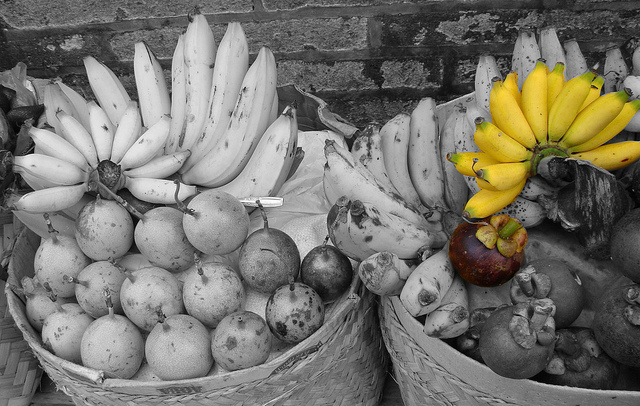Please provide the bounding box coordinate of the region this sentence describes: yellow bananas. The region corresponding to 'yellow bananas' is located at coordinates [0.69, 0.27, 1.0, 0.52]. 